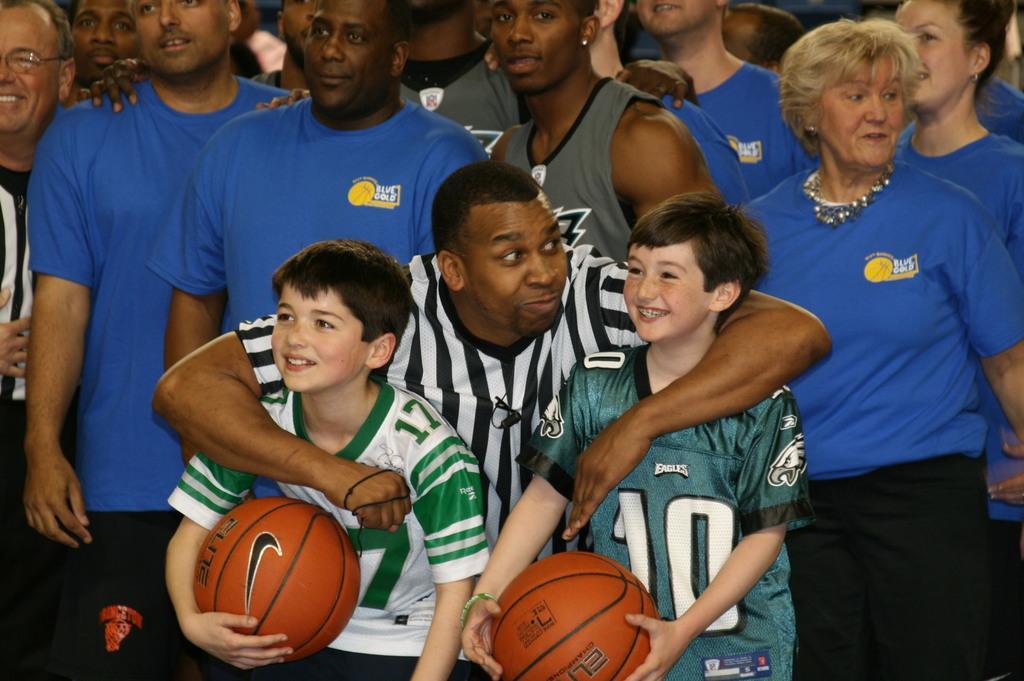Can you describe this image briefly? In this picture I can see the two children holding the balls in the foreground. I can see a few people in the background. 